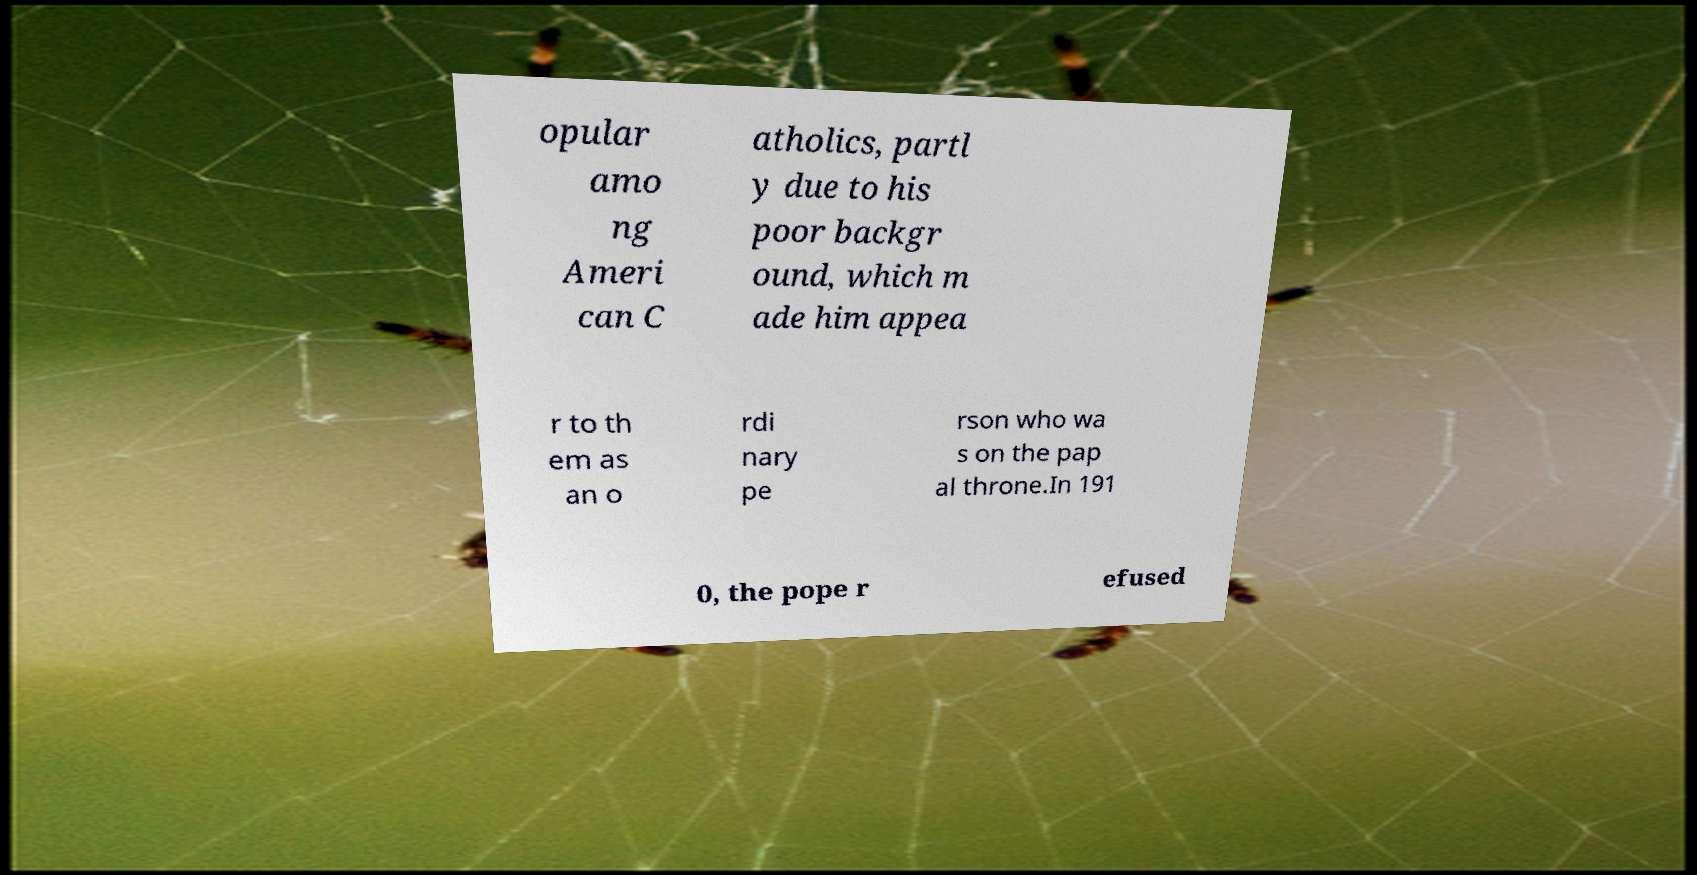What messages or text are displayed in this image? I need them in a readable, typed format. opular amo ng Ameri can C atholics, partl y due to his poor backgr ound, which m ade him appea r to th em as an o rdi nary pe rson who wa s on the pap al throne.In 191 0, the pope r efused 